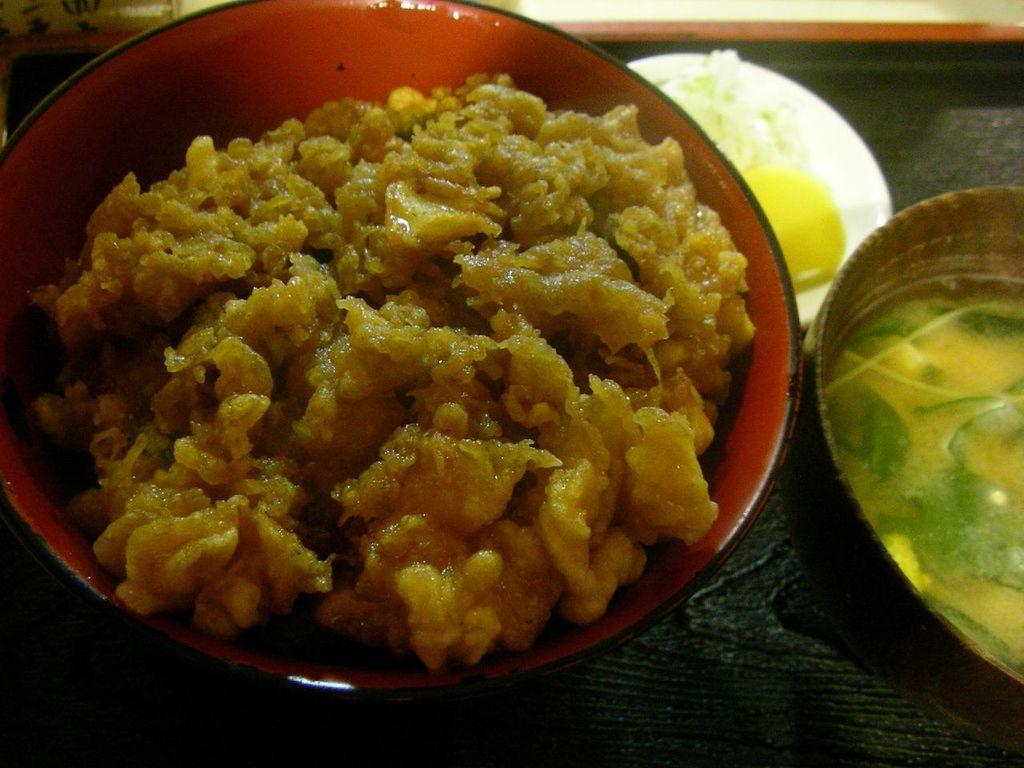Describe this image in one or two sentences. In this image we can see food item and soup in the bowls on a platform and we can also see items in a plate on the platform. 